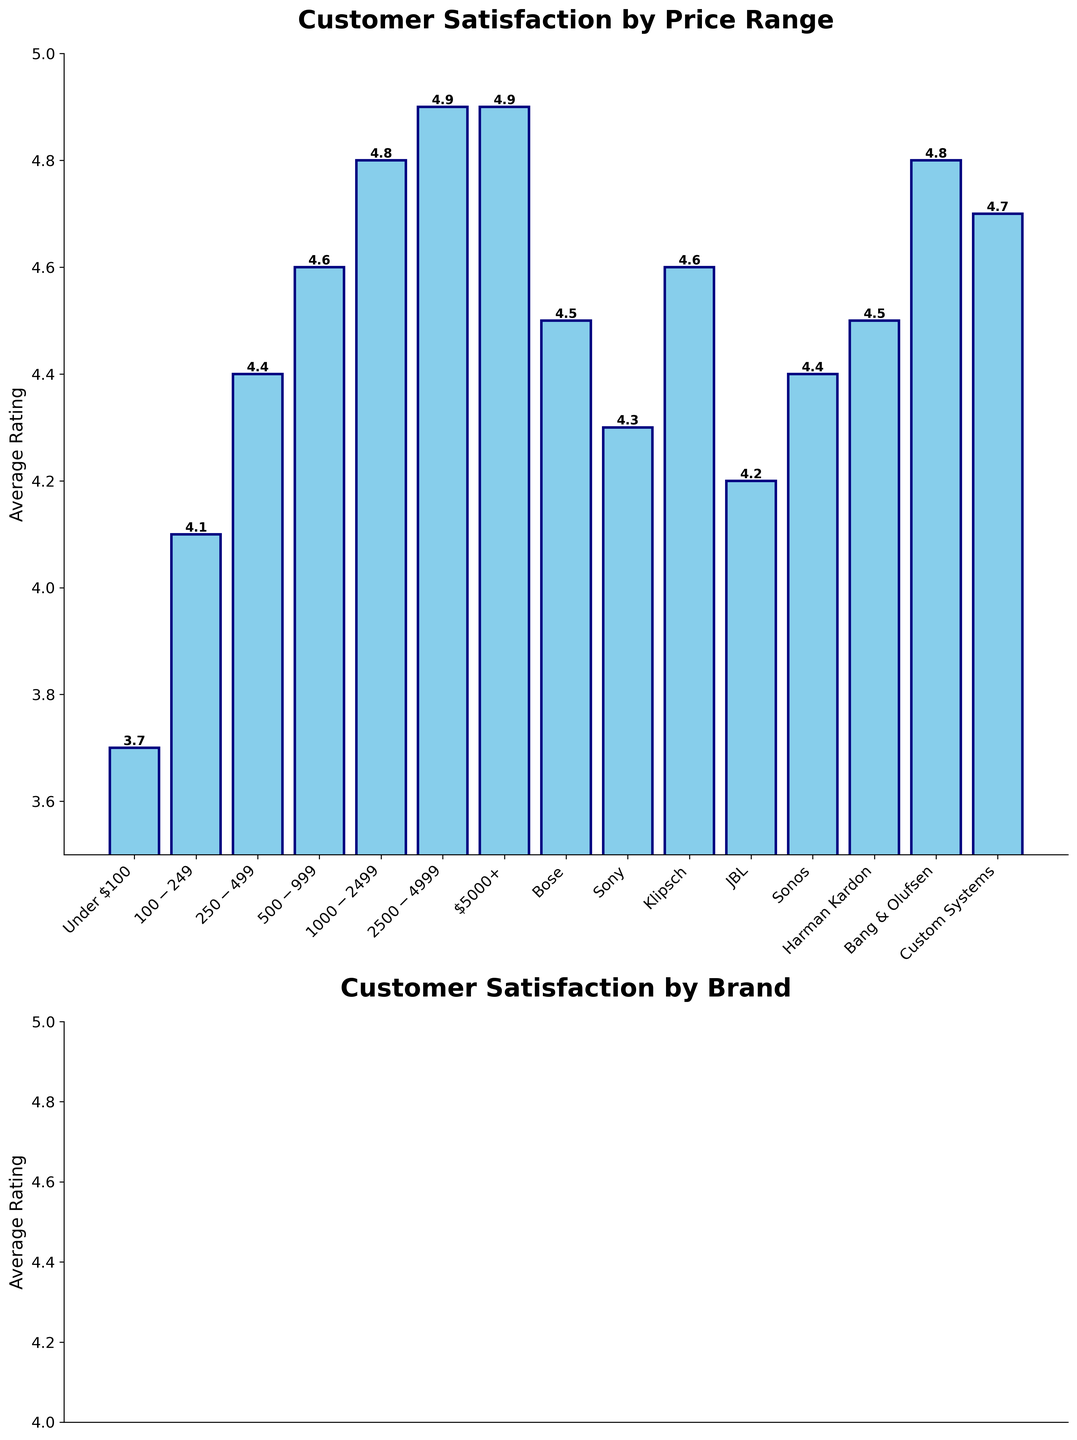What is the average customer satisfaction rating for speaker systems priced between $1000 and $2499? The bar corresponding to the $1000-$2499 price range shows an average customer satisfaction rating of 4.8.
Answer: 4.8 Which price range has the lowest customer satisfaction rating? The shortest bar in the price range section represents the "Under $100" category, with a rating of 3.7, which is the lowest.
Answer: Under $100 Is there any brand with a customer satisfaction rating equal to the highest rating in any price range? If yes, name it. The highest rating in any price range is 4.9 for "Price: $2500-$4999" and "$5000+". The bar for "Bang & Olufsen" also shows a rating of 4.8, thus there is no exact match.
Answer: No Comparing Bose and JBL, which brand has a higher customer satisfaction rating? The bar for Bose shows a rating of 4.5, whereas the bar for JBL shows 4.2. Bose has a higher rating.
Answer: Bose What is the difference in customer satisfaction ratings between the $2500-$4999 price range and the $100-$249 price range? The bar for the $2500-$4999 price range shows a rating of 4.9, and the bar for the $100-$249 price range shows 4.1. The difference is 4.9 - 4.1 = 0.8.
Answer: 0.8 Which brand has the highest customer satisfaction rating, and what is it? The tallest bar in the brands section is for "Bang & Olufsen", with a rating of 4.8.
Answer: Bang & Olufsen, 4.8 Between the custom systems and the brand with the lowest rating, what is the difference in customer satisfaction ratings? The rating for the custom systems is 4.7, while the lowest brand rating shown is JBL at 4.2. The difference is 4.7 - 4.2 = 0.5.
Answer: 0.5 If you average customer satisfaction ratings for speaker systems priced under $500, what is the result? The ratings for under $100, $100-$249 and $250-$499 are 3.7, 4.1, and 4.4, respectively. The average is (3.7 + 4.1 + 4.4)/3 = 4.07.
Answer: 4.07 